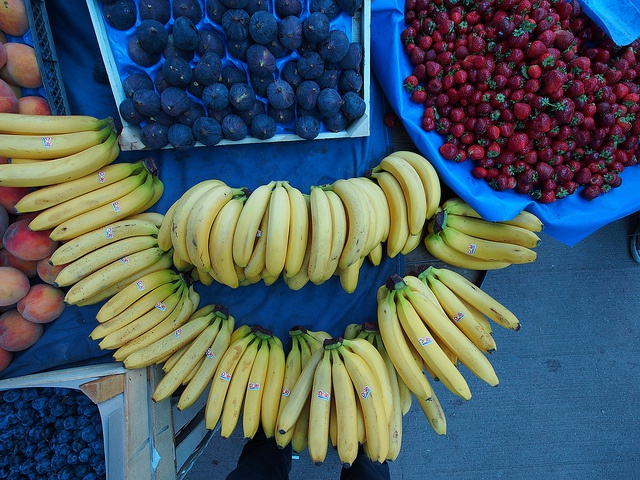Describe the objects in this image and their specific colors. I can see banana in gray, olive, and beige tones, banana in gray, tan, khaki, and darkgreen tones, banana in gray, tan, khaki, and olive tones, banana in gray, tan, and olive tones, and banana in gray, tan, beige, and olive tones in this image. 